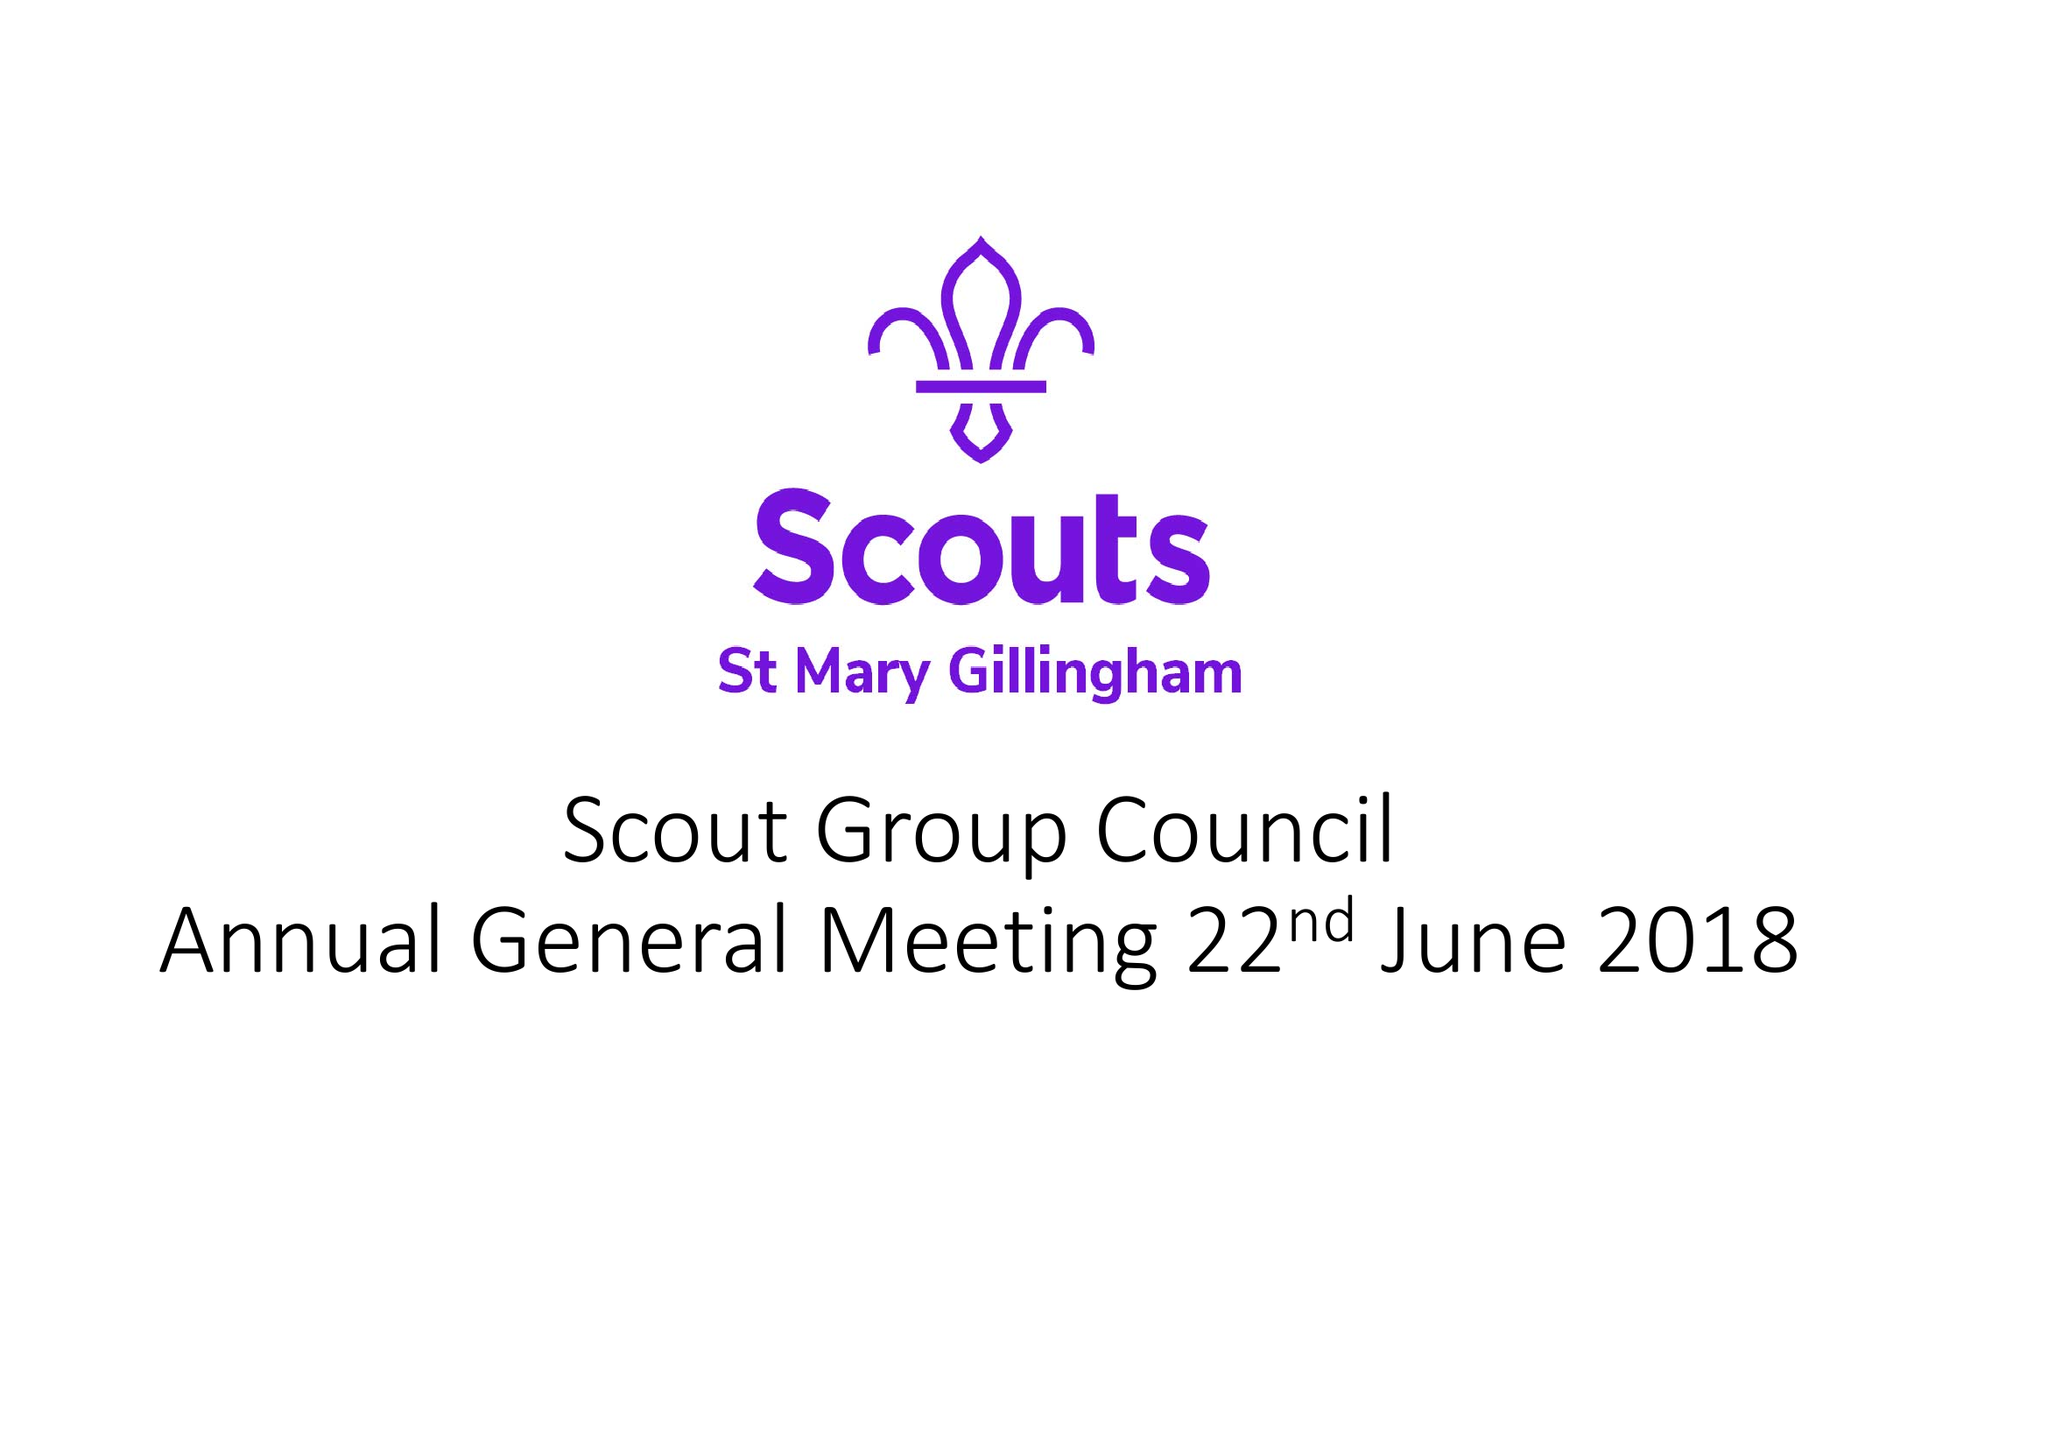What is the value for the charity_number?
Answer the question using a single word or phrase. 1023375 